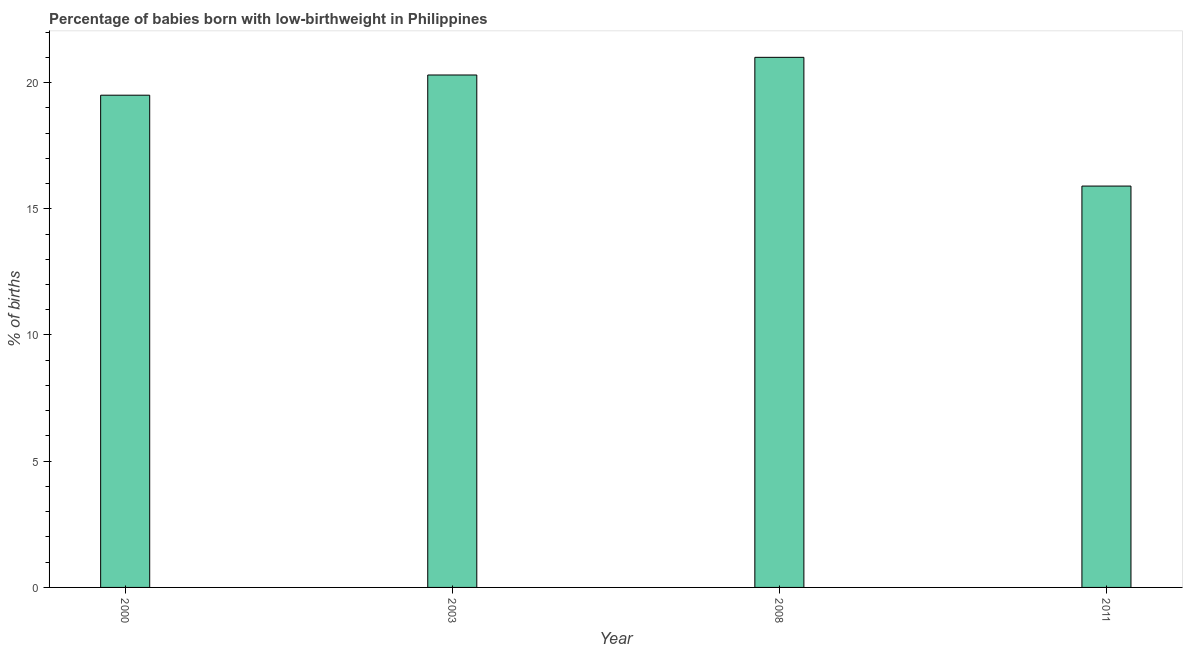Does the graph contain grids?
Make the answer very short. No. What is the title of the graph?
Give a very brief answer. Percentage of babies born with low-birthweight in Philippines. What is the label or title of the Y-axis?
Your answer should be compact. % of births. What is the percentage of babies who were born with low-birthweight in 2003?
Your answer should be very brief. 20.3. In which year was the percentage of babies who were born with low-birthweight minimum?
Make the answer very short. 2011. What is the sum of the percentage of babies who were born with low-birthweight?
Offer a very short reply. 76.7. What is the difference between the percentage of babies who were born with low-birthweight in 2008 and 2011?
Offer a very short reply. 5.1. What is the average percentage of babies who were born with low-birthweight per year?
Your response must be concise. 19.18. What is the median percentage of babies who were born with low-birthweight?
Give a very brief answer. 19.9. In how many years, is the percentage of babies who were born with low-birthweight greater than 5 %?
Keep it short and to the point. 4. What is the ratio of the percentage of babies who were born with low-birthweight in 2003 to that in 2011?
Your answer should be very brief. 1.28. Is the percentage of babies who were born with low-birthweight in 2000 less than that in 2008?
Ensure brevity in your answer.  Yes. Is the difference between the percentage of babies who were born with low-birthweight in 2003 and 2008 greater than the difference between any two years?
Offer a very short reply. No. Is the sum of the percentage of babies who were born with low-birthweight in 2008 and 2011 greater than the maximum percentage of babies who were born with low-birthweight across all years?
Offer a terse response. Yes. In how many years, is the percentage of babies who were born with low-birthweight greater than the average percentage of babies who were born with low-birthweight taken over all years?
Your response must be concise. 3. What is the difference between two consecutive major ticks on the Y-axis?
Provide a short and direct response. 5. Are the values on the major ticks of Y-axis written in scientific E-notation?
Keep it short and to the point. No. What is the % of births of 2000?
Your response must be concise. 19.5. What is the % of births of 2003?
Give a very brief answer. 20.3. What is the % of births of 2008?
Provide a succinct answer. 21. What is the difference between the % of births in 2000 and 2008?
Your answer should be very brief. -1.5. What is the difference between the % of births in 2000 and 2011?
Your answer should be very brief. 3.6. What is the difference between the % of births in 2008 and 2011?
Offer a terse response. 5.1. What is the ratio of the % of births in 2000 to that in 2008?
Your answer should be very brief. 0.93. What is the ratio of the % of births in 2000 to that in 2011?
Provide a succinct answer. 1.23. What is the ratio of the % of births in 2003 to that in 2011?
Offer a terse response. 1.28. What is the ratio of the % of births in 2008 to that in 2011?
Ensure brevity in your answer.  1.32. 